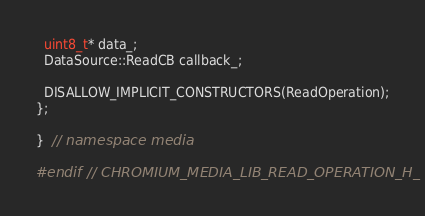<code> <loc_0><loc_0><loc_500><loc_500><_C_>  uint8_t* data_;
  DataSource::ReadCB callback_;

  DISALLOW_IMPLICIT_CONSTRUCTORS(ReadOperation);
};

}  // namespace media

#endif  // CHROMIUM_MEDIA_LIB_READ_OPERATION_H_
</code> 